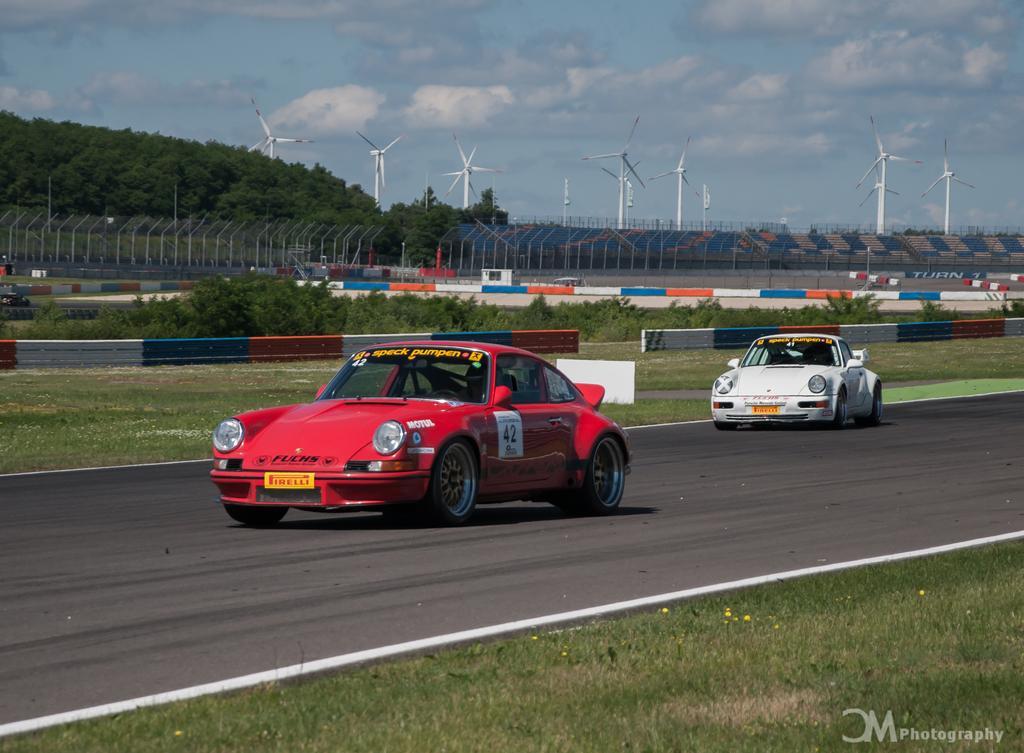In one or two sentences, can you explain what this image depicts? In the foreground of this image, there are two cars moving on the road and on either side, there are trees, fencing poles, stadium, wind fans, sky and the cloud. 